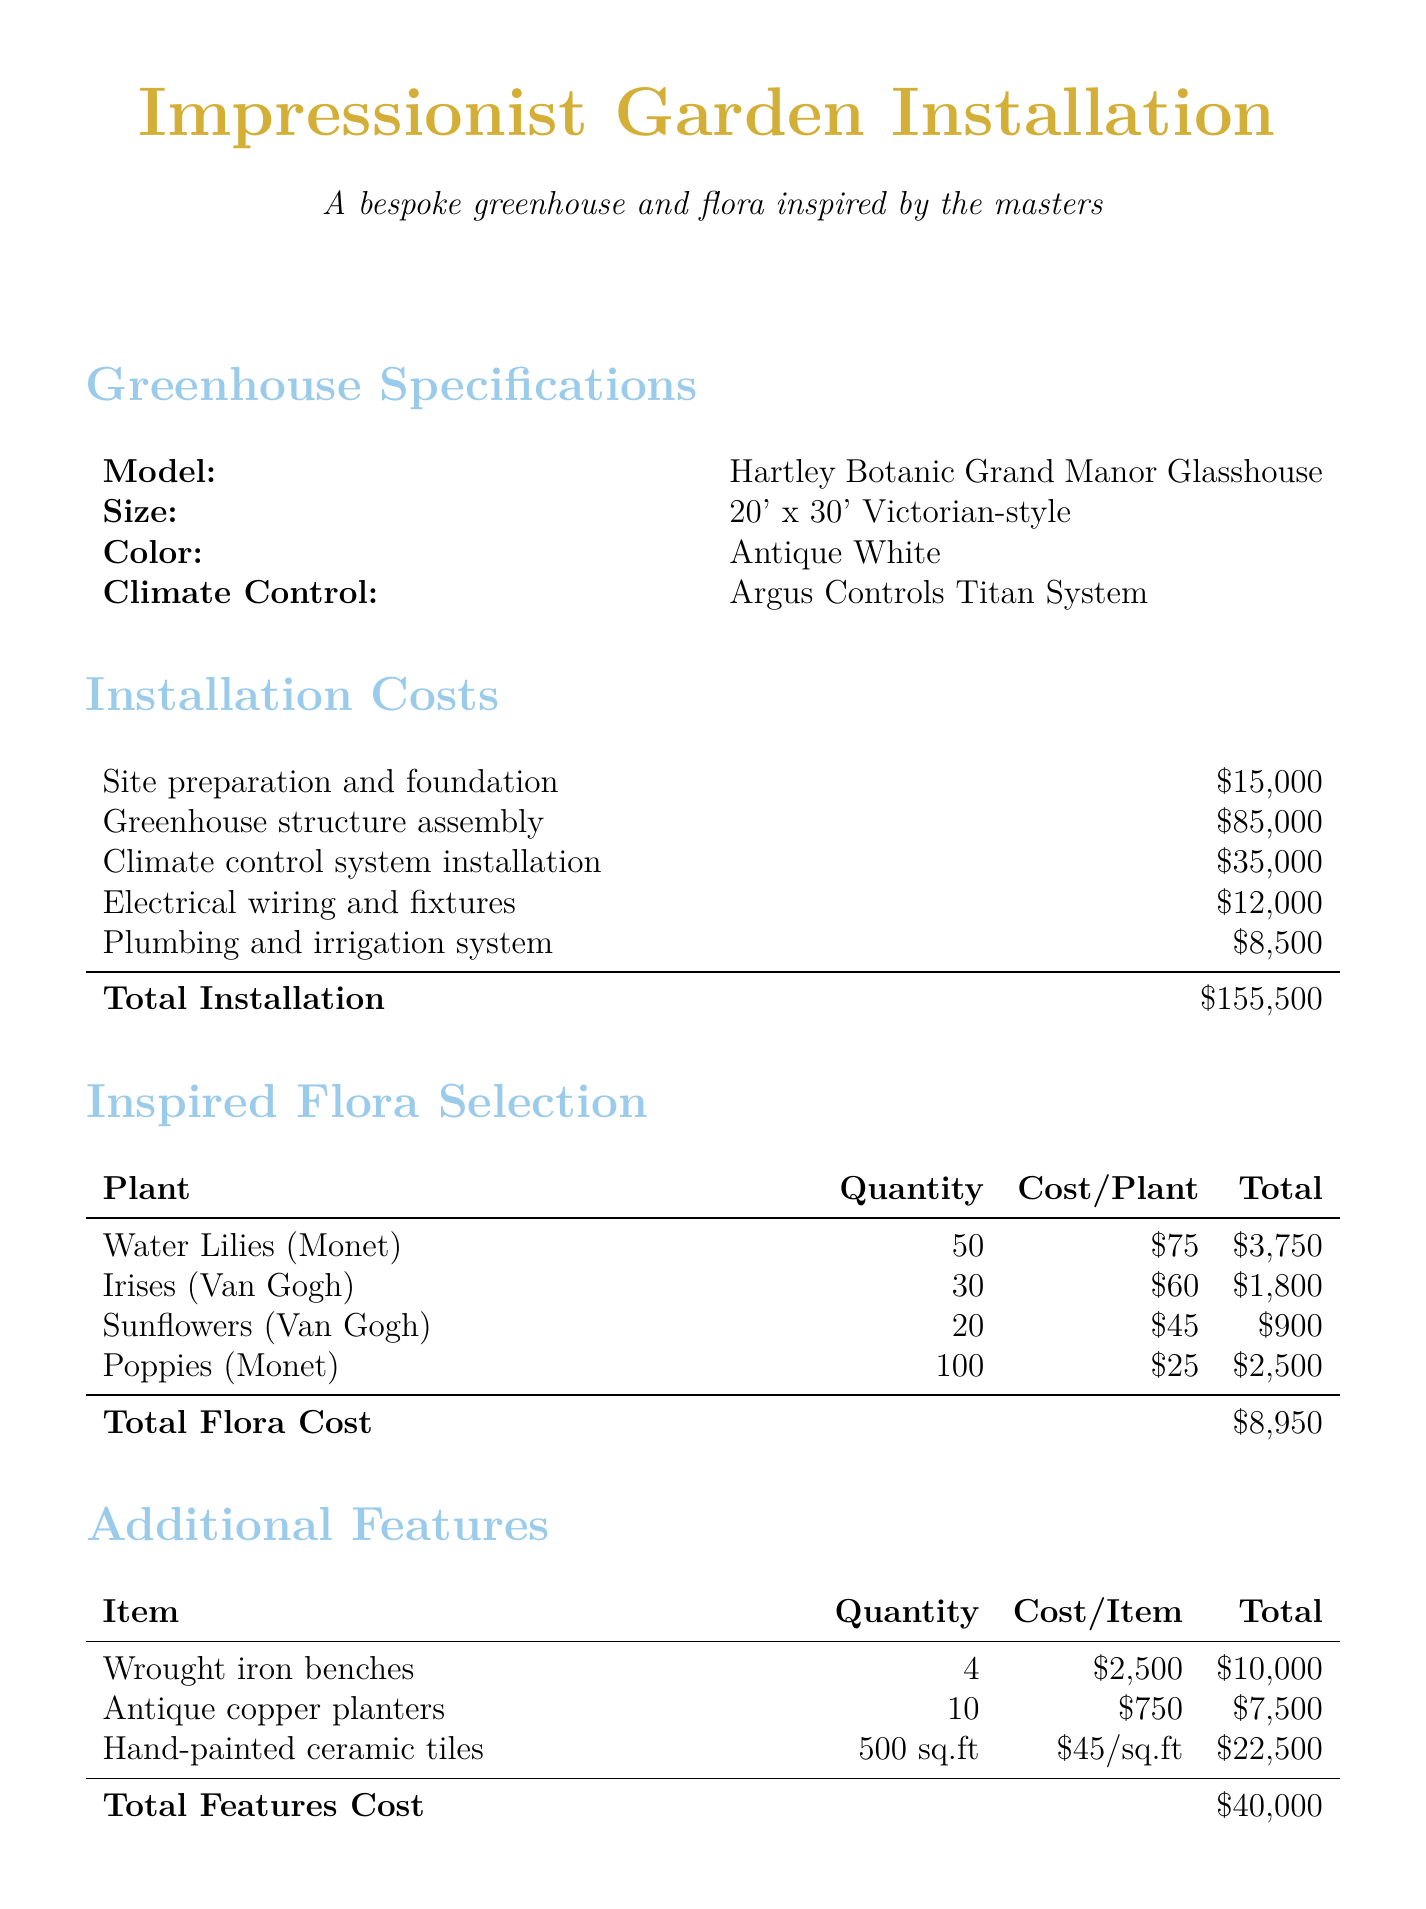what is the size of the greenhouse? The size of the greenhouse is specified as 20' x 30'.
Answer: 20' x 30' who is the manufacturer of the greenhouse? The manufacturer of the greenhouse is Hartley Botanic.
Answer: Hartley Botanic what is the total installation cost? The total installation cost is calculated by summing up all individual installation costs in the document.
Answer: $155,500 how many Irises are selected for planting? The document states the quantity of Irises to be planted is 30.
Answer: 30 what is the total cost of the inspired flora? The total cost of the inspired flora is found by summing the costs of all selected plants.
Answer: $8,950 how many hours of work is the landscape architect service billed for? The document shows that the landscape architect service is billed for 60 hours of work.
Answer: 60 what is the cost for custom-designed wrought iron benches? The cost for custom-designed wrought iron benches is derived from multiplying the quantity by cost per item.
Answer: $10,000 how many services are included in the maintenance plan? The maintenance plan includes four specific services as listed in the document.
Answer: 4 what is the rate per hour for the art historian's service? The document specifies the rate per hour for the art historian's service as $300.
Answer: $300 